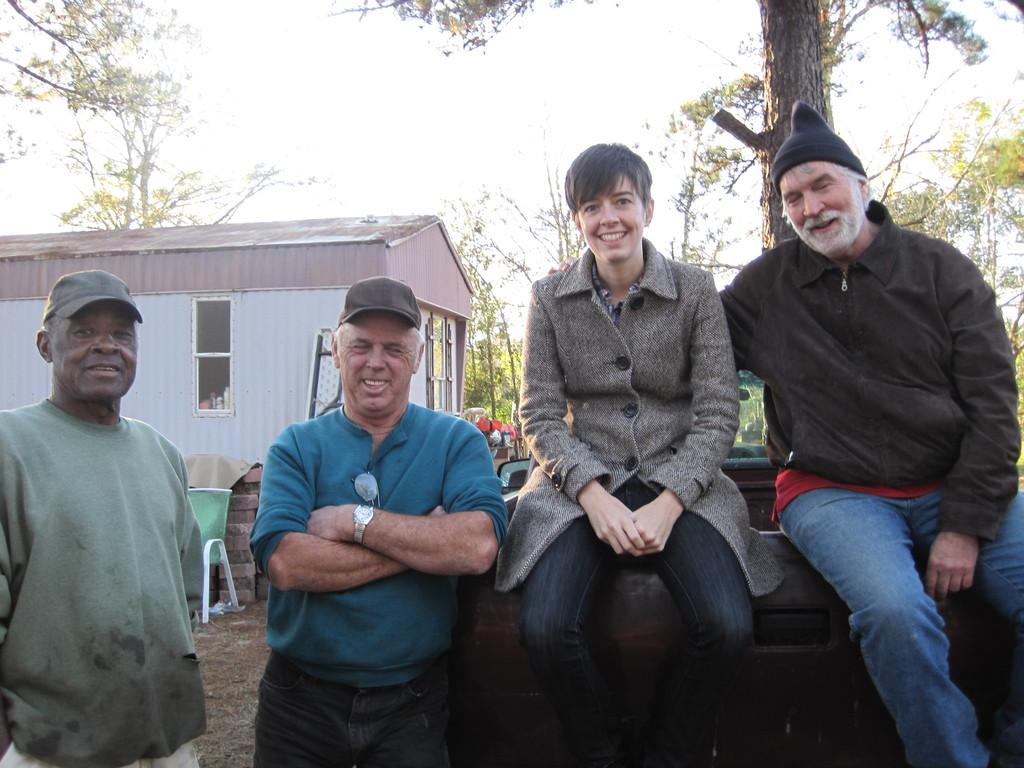How many people are sitting in the image? There are two people sitting in the image. What are the people standing next to the sitting people doing? The people standing next to the sitting people are likely interacting with them, but the specific activity cannot be determined from the facts. What can be seen in the background of the image? There is a shed and trees visible in the background of the image. What is visible at the top of the image? The sky is visible in the image. What language are the yaks speaking in the image? There are no yaks present in the image, so it is not possible to determine what language they might be speaking. 